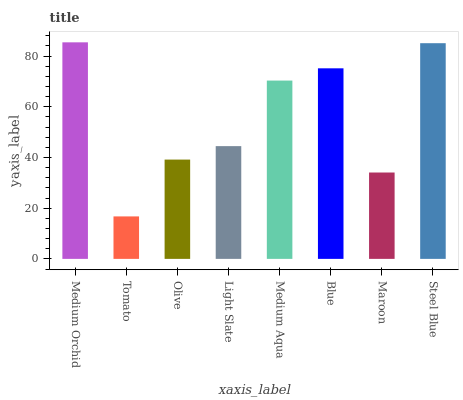Is Tomato the minimum?
Answer yes or no. Yes. Is Medium Orchid the maximum?
Answer yes or no. Yes. Is Olive the minimum?
Answer yes or no. No. Is Olive the maximum?
Answer yes or no. No. Is Olive greater than Tomato?
Answer yes or no. Yes. Is Tomato less than Olive?
Answer yes or no. Yes. Is Tomato greater than Olive?
Answer yes or no. No. Is Olive less than Tomato?
Answer yes or no. No. Is Medium Aqua the high median?
Answer yes or no. Yes. Is Light Slate the low median?
Answer yes or no. Yes. Is Light Slate the high median?
Answer yes or no. No. Is Tomato the low median?
Answer yes or no. No. 